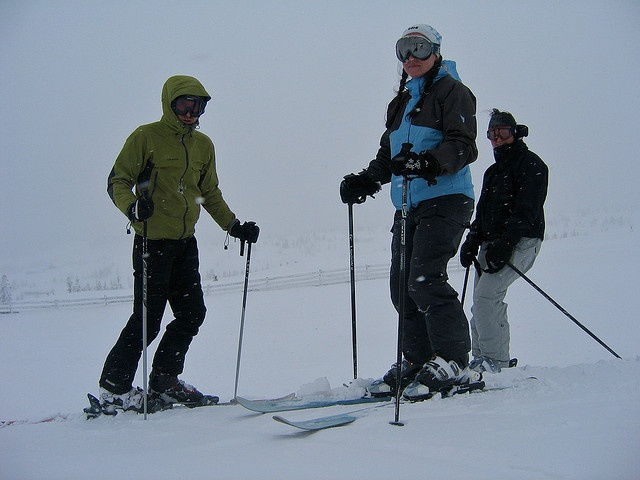Describe the objects in this image and their specific colors. I can see people in gray, black, blue, and teal tones, people in gray, black, and darkgreen tones, people in gray, black, darkgray, and blue tones, skis in gray, darkgray, and black tones, and skis in gray, darkgray, and black tones in this image. 